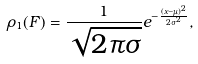<formula> <loc_0><loc_0><loc_500><loc_500>\rho _ { 1 } ( F ) = \frac { 1 } { \sqrt { 2 \pi \sigma } } e ^ { - \frac { ( x - \mu ) ^ { 2 } } { 2 \sigma ^ { 2 } } } ,</formula> 